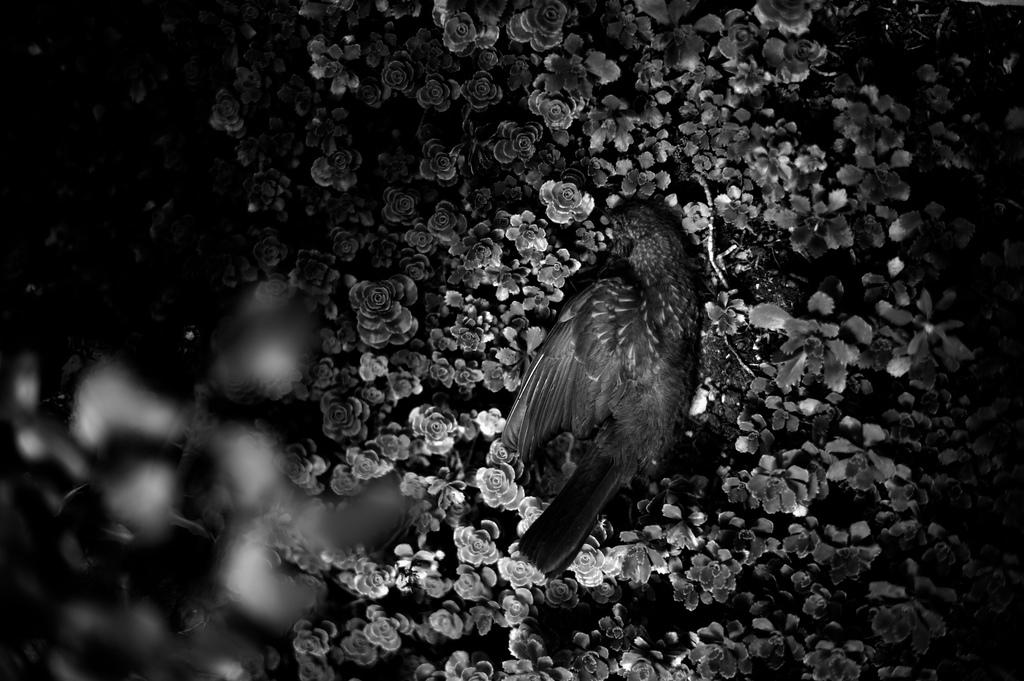What is the color scheme of the image? The image is black and white. What type of animal can be seen in the image? There is a bird in the image. What other elements are present in the image besides the bird? There is a group of plants in the image. Where is the volleyball court located in the image? There is no volleyball court present in the image. What type of street is visible in the image? There is no street visible in the image. 